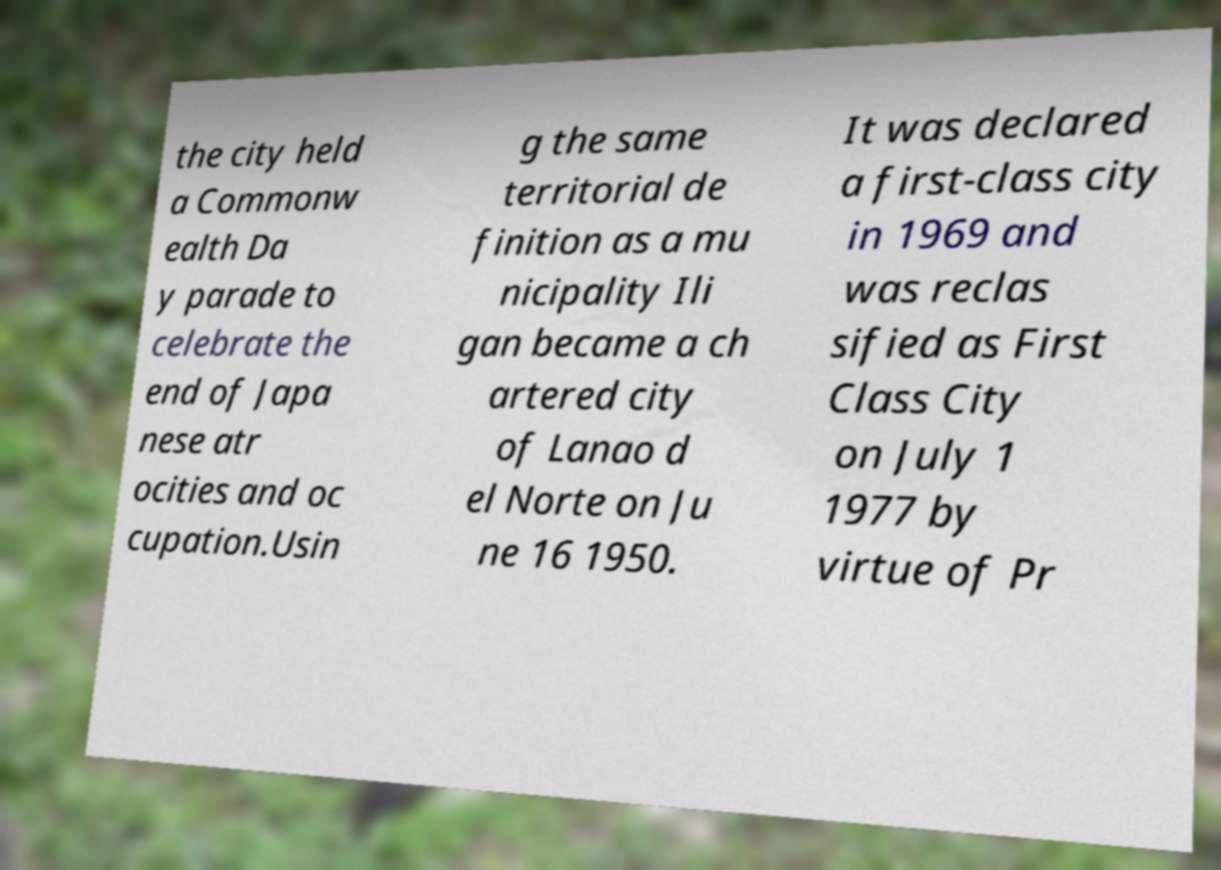Can you read and provide the text displayed in the image?This photo seems to have some interesting text. Can you extract and type it out for me? the city held a Commonw ealth Da y parade to celebrate the end of Japa nese atr ocities and oc cupation.Usin g the same territorial de finition as a mu nicipality Ili gan became a ch artered city of Lanao d el Norte on Ju ne 16 1950. It was declared a first-class city in 1969 and was reclas sified as First Class City on July 1 1977 by virtue of Pr 